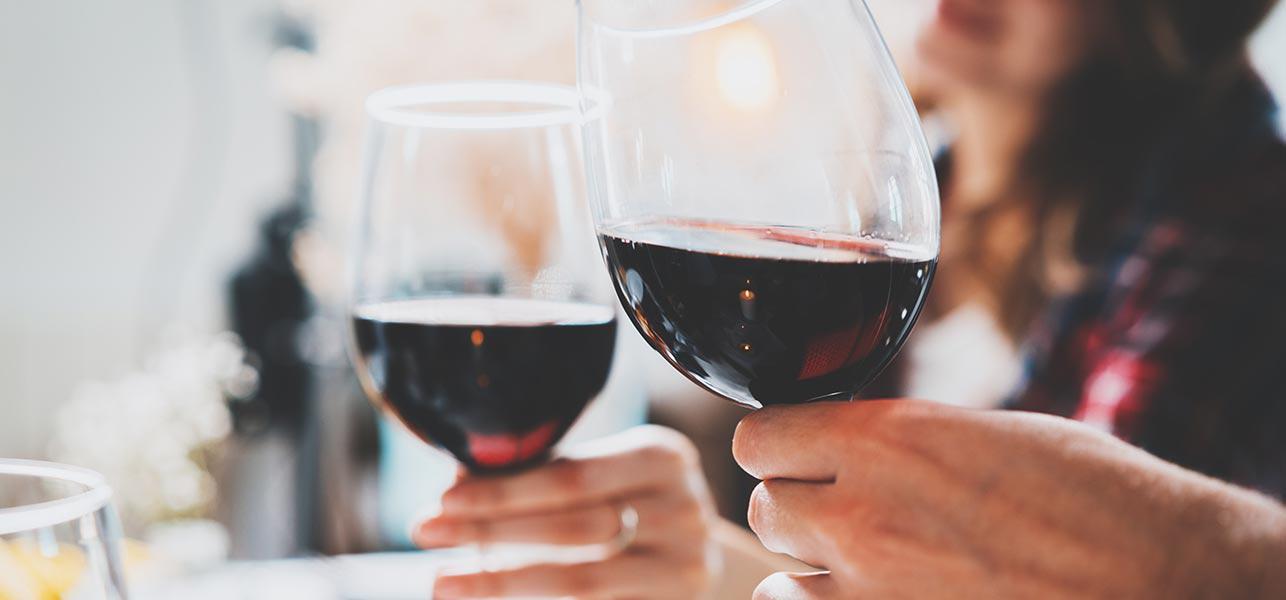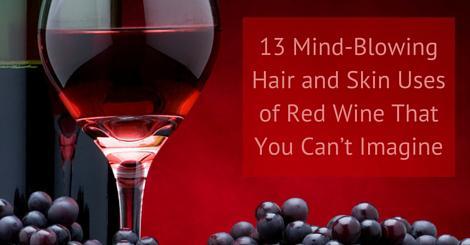The first image is the image on the left, the second image is the image on the right. Assess this claim about the two images: "At least one image shows wine bottles stored in a rack.". Correct or not? Answer yes or no. No. 